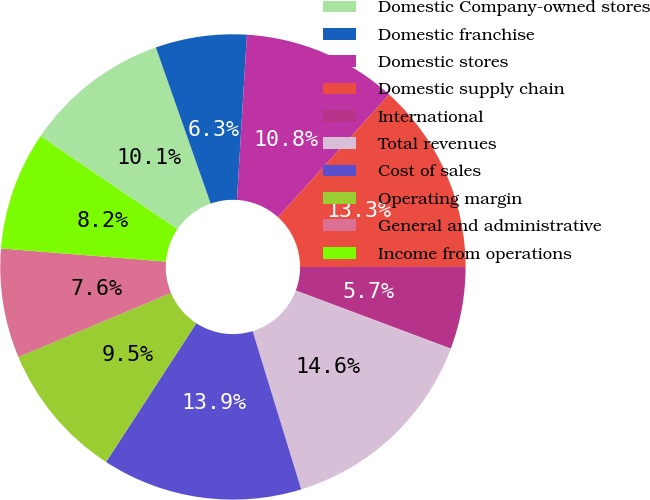Convert chart. <chart><loc_0><loc_0><loc_500><loc_500><pie_chart><fcel>Domestic Company-owned stores<fcel>Domestic franchise<fcel>Domestic stores<fcel>Domestic supply chain<fcel>International<fcel>Total revenues<fcel>Cost of sales<fcel>Operating margin<fcel>General and administrative<fcel>Income from operations<nl><fcel>10.13%<fcel>6.33%<fcel>10.76%<fcel>13.29%<fcel>5.7%<fcel>14.55%<fcel>13.92%<fcel>9.49%<fcel>7.6%<fcel>8.23%<nl></chart> 